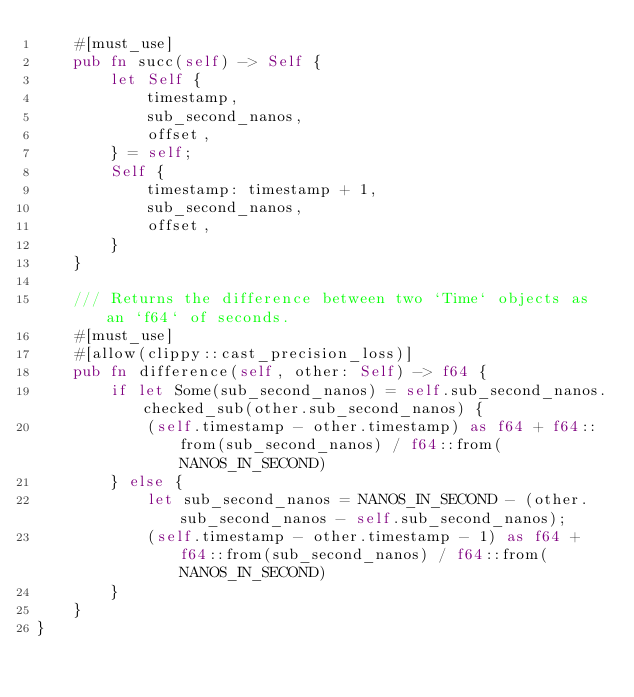<code> <loc_0><loc_0><loc_500><loc_500><_Rust_>    #[must_use]
    pub fn succ(self) -> Self {
        let Self {
            timestamp,
            sub_second_nanos,
            offset,
        } = self;
        Self {
            timestamp: timestamp + 1,
            sub_second_nanos,
            offset,
        }
    }

    /// Returns the difference between two `Time` objects as an `f64` of seconds.
    #[must_use]
    #[allow(clippy::cast_precision_loss)]
    pub fn difference(self, other: Self) -> f64 {
        if let Some(sub_second_nanos) = self.sub_second_nanos.checked_sub(other.sub_second_nanos) {
            (self.timestamp - other.timestamp) as f64 + f64::from(sub_second_nanos) / f64::from(NANOS_IN_SECOND)
        } else {
            let sub_second_nanos = NANOS_IN_SECOND - (other.sub_second_nanos - self.sub_second_nanos);
            (self.timestamp - other.timestamp - 1) as f64 + f64::from(sub_second_nanos) / f64::from(NANOS_IN_SECOND)
        }
    }
}
</code> 